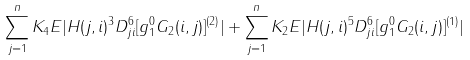<formula> <loc_0><loc_0><loc_500><loc_500>\sum _ { j = 1 } ^ { n } K _ { 4 } { E } | H ( j , i ) ^ { 3 } D ^ { 6 } _ { j i } [ g ^ { 0 } _ { 1 } G _ { 2 } ( i , j ) ] ^ { ( 2 ) } | + \sum _ { j = 1 } ^ { n } K _ { 2 } { E } | H ( j , i ) ^ { 5 } D ^ { 6 } _ { j i } [ g ^ { 0 } _ { 1 } G _ { 2 } ( i , j ) ] ^ { ( 1 ) } |</formula> 